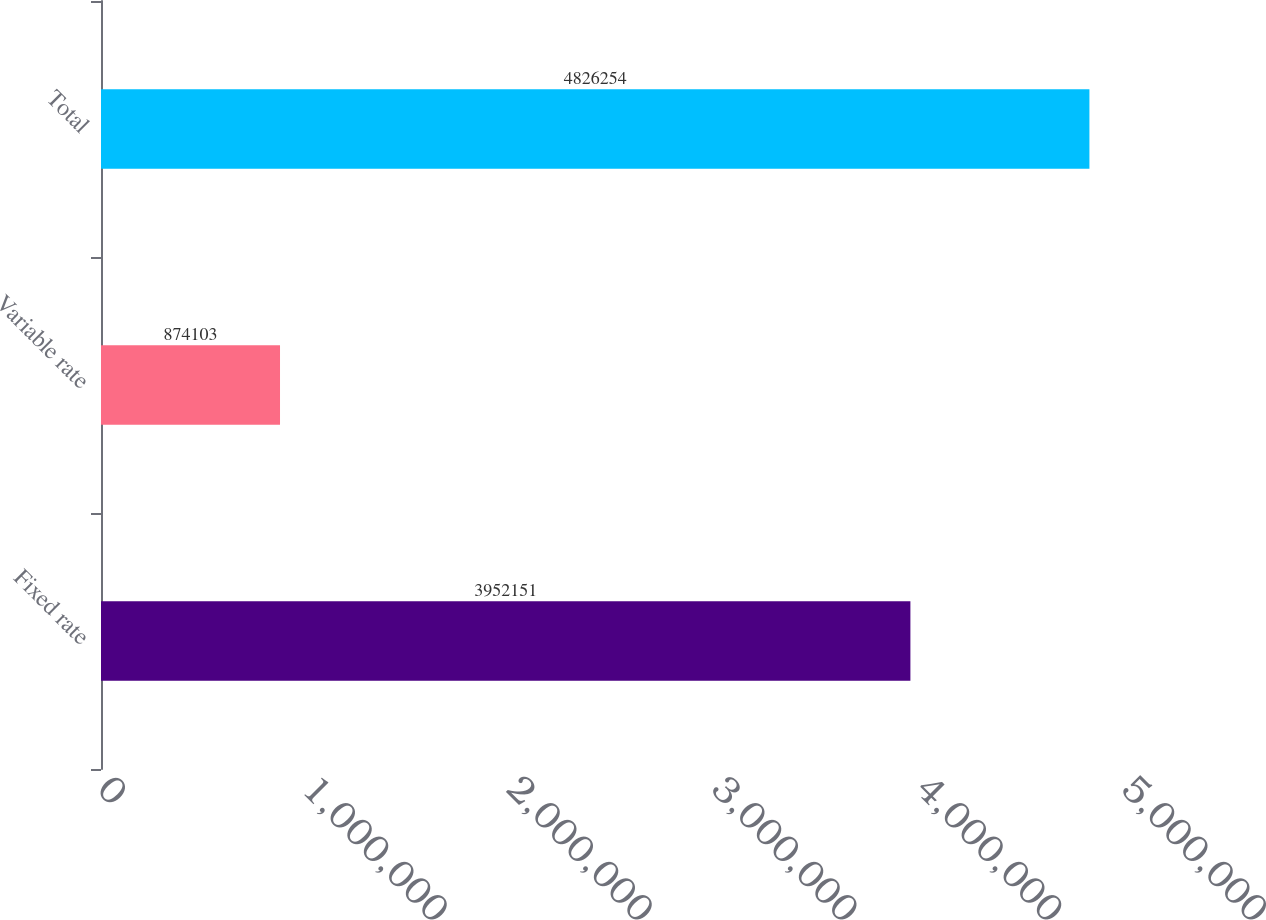Convert chart to OTSL. <chart><loc_0><loc_0><loc_500><loc_500><bar_chart><fcel>Fixed rate<fcel>Variable rate<fcel>Total<nl><fcel>3.95215e+06<fcel>874103<fcel>4.82625e+06<nl></chart> 